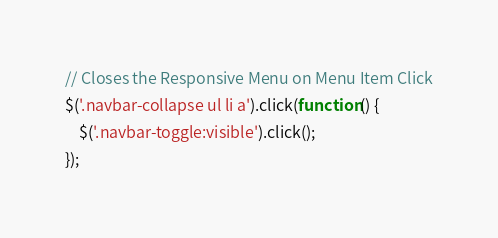Convert code to text. <code><loc_0><loc_0><loc_500><loc_500><_JavaScript_>// Closes the Responsive Menu on Menu Item Click
$('.navbar-collapse ul li a').click(function() {
    $('.navbar-toggle:visible').click();
});
</code> 